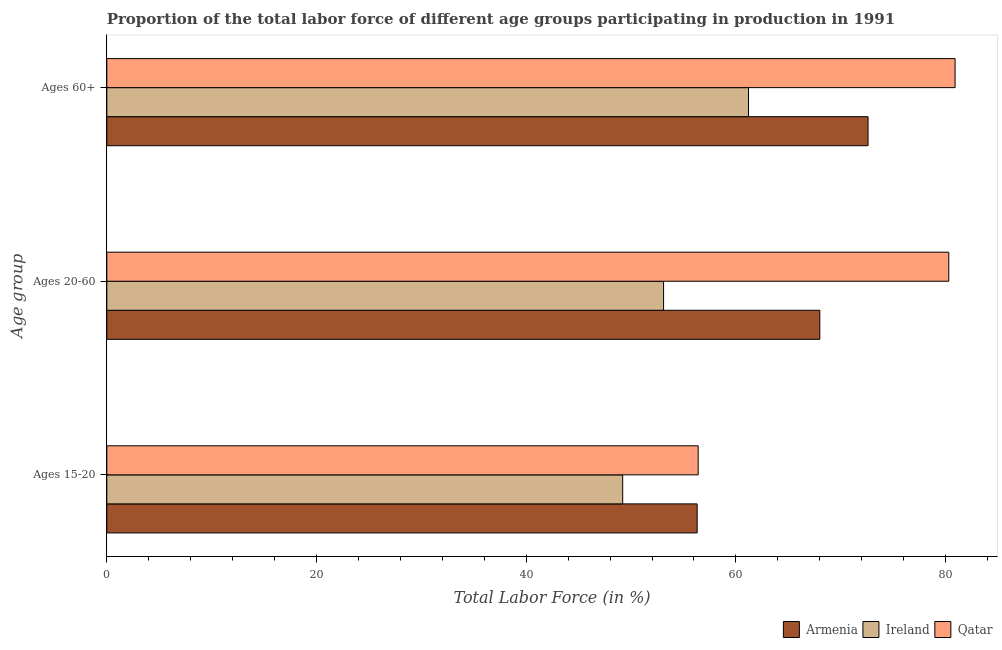How many different coloured bars are there?
Make the answer very short. 3. How many bars are there on the 1st tick from the top?
Offer a very short reply. 3. What is the label of the 1st group of bars from the top?
Offer a terse response. Ages 60+. What is the percentage of labor force within the age group 15-20 in Armenia?
Offer a terse response. 56.3. Across all countries, what is the maximum percentage of labor force within the age group 15-20?
Offer a terse response. 56.4. Across all countries, what is the minimum percentage of labor force within the age group 15-20?
Your answer should be compact. 49.2. In which country was the percentage of labor force within the age group 20-60 maximum?
Keep it short and to the point. Qatar. In which country was the percentage of labor force within the age group 15-20 minimum?
Your answer should be very brief. Ireland. What is the total percentage of labor force within the age group 20-60 in the graph?
Offer a terse response. 201.4. What is the difference between the percentage of labor force above age 60 in Qatar and that in Ireland?
Provide a short and direct response. 19.7. What is the difference between the percentage of labor force above age 60 in Armenia and the percentage of labor force within the age group 20-60 in Ireland?
Your answer should be compact. 19.5. What is the average percentage of labor force above age 60 per country?
Offer a terse response. 71.57. What is the difference between the percentage of labor force within the age group 20-60 and percentage of labor force within the age group 15-20 in Armenia?
Your response must be concise. 11.7. In how many countries, is the percentage of labor force within the age group 15-20 greater than 32 %?
Make the answer very short. 3. What is the ratio of the percentage of labor force within the age group 20-60 in Armenia to that in Qatar?
Give a very brief answer. 0.85. Is the percentage of labor force within the age group 15-20 in Ireland less than that in Armenia?
Give a very brief answer. Yes. Is the difference between the percentage of labor force within the age group 20-60 in Qatar and Ireland greater than the difference between the percentage of labor force within the age group 15-20 in Qatar and Ireland?
Ensure brevity in your answer.  Yes. What is the difference between the highest and the second highest percentage of labor force within the age group 15-20?
Offer a terse response. 0.1. What is the difference between the highest and the lowest percentage of labor force within the age group 15-20?
Ensure brevity in your answer.  7.2. In how many countries, is the percentage of labor force within the age group 15-20 greater than the average percentage of labor force within the age group 15-20 taken over all countries?
Your answer should be very brief. 2. What does the 2nd bar from the top in Ages 20-60 represents?
Ensure brevity in your answer.  Ireland. What does the 1st bar from the bottom in Ages 60+ represents?
Offer a very short reply. Armenia. Is it the case that in every country, the sum of the percentage of labor force within the age group 15-20 and percentage of labor force within the age group 20-60 is greater than the percentage of labor force above age 60?
Provide a short and direct response. Yes. What is the difference between two consecutive major ticks on the X-axis?
Offer a terse response. 20. Where does the legend appear in the graph?
Your answer should be very brief. Bottom right. How are the legend labels stacked?
Give a very brief answer. Horizontal. What is the title of the graph?
Ensure brevity in your answer.  Proportion of the total labor force of different age groups participating in production in 1991. Does "Bolivia" appear as one of the legend labels in the graph?
Your response must be concise. No. What is the label or title of the Y-axis?
Provide a succinct answer. Age group. What is the Total Labor Force (in %) of Armenia in Ages 15-20?
Make the answer very short. 56.3. What is the Total Labor Force (in %) of Ireland in Ages 15-20?
Ensure brevity in your answer.  49.2. What is the Total Labor Force (in %) of Qatar in Ages 15-20?
Make the answer very short. 56.4. What is the Total Labor Force (in %) of Ireland in Ages 20-60?
Make the answer very short. 53.1. What is the Total Labor Force (in %) of Qatar in Ages 20-60?
Provide a succinct answer. 80.3. What is the Total Labor Force (in %) of Armenia in Ages 60+?
Your answer should be compact. 72.6. What is the Total Labor Force (in %) in Ireland in Ages 60+?
Provide a short and direct response. 61.2. What is the Total Labor Force (in %) of Qatar in Ages 60+?
Offer a terse response. 80.9. Across all Age group, what is the maximum Total Labor Force (in %) in Armenia?
Give a very brief answer. 72.6. Across all Age group, what is the maximum Total Labor Force (in %) of Ireland?
Ensure brevity in your answer.  61.2. Across all Age group, what is the maximum Total Labor Force (in %) of Qatar?
Offer a terse response. 80.9. Across all Age group, what is the minimum Total Labor Force (in %) in Armenia?
Your answer should be very brief. 56.3. Across all Age group, what is the minimum Total Labor Force (in %) of Ireland?
Offer a terse response. 49.2. Across all Age group, what is the minimum Total Labor Force (in %) in Qatar?
Your answer should be compact. 56.4. What is the total Total Labor Force (in %) of Armenia in the graph?
Make the answer very short. 196.9. What is the total Total Labor Force (in %) of Ireland in the graph?
Offer a very short reply. 163.5. What is the total Total Labor Force (in %) of Qatar in the graph?
Your answer should be very brief. 217.6. What is the difference between the Total Labor Force (in %) in Armenia in Ages 15-20 and that in Ages 20-60?
Give a very brief answer. -11.7. What is the difference between the Total Labor Force (in %) in Qatar in Ages 15-20 and that in Ages 20-60?
Provide a short and direct response. -23.9. What is the difference between the Total Labor Force (in %) in Armenia in Ages 15-20 and that in Ages 60+?
Keep it short and to the point. -16.3. What is the difference between the Total Labor Force (in %) of Ireland in Ages 15-20 and that in Ages 60+?
Your response must be concise. -12. What is the difference between the Total Labor Force (in %) in Qatar in Ages 15-20 and that in Ages 60+?
Your answer should be very brief. -24.5. What is the difference between the Total Labor Force (in %) in Armenia in Ages 20-60 and that in Ages 60+?
Your answer should be compact. -4.6. What is the difference between the Total Labor Force (in %) in Qatar in Ages 20-60 and that in Ages 60+?
Your answer should be compact. -0.6. What is the difference between the Total Labor Force (in %) in Armenia in Ages 15-20 and the Total Labor Force (in %) in Qatar in Ages 20-60?
Offer a terse response. -24. What is the difference between the Total Labor Force (in %) in Ireland in Ages 15-20 and the Total Labor Force (in %) in Qatar in Ages 20-60?
Provide a succinct answer. -31.1. What is the difference between the Total Labor Force (in %) in Armenia in Ages 15-20 and the Total Labor Force (in %) in Qatar in Ages 60+?
Keep it short and to the point. -24.6. What is the difference between the Total Labor Force (in %) of Ireland in Ages 15-20 and the Total Labor Force (in %) of Qatar in Ages 60+?
Offer a terse response. -31.7. What is the difference between the Total Labor Force (in %) of Armenia in Ages 20-60 and the Total Labor Force (in %) of Ireland in Ages 60+?
Offer a very short reply. 6.8. What is the difference between the Total Labor Force (in %) in Armenia in Ages 20-60 and the Total Labor Force (in %) in Qatar in Ages 60+?
Ensure brevity in your answer.  -12.9. What is the difference between the Total Labor Force (in %) in Ireland in Ages 20-60 and the Total Labor Force (in %) in Qatar in Ages 60+?
Your response must be concise. -27.8. What is the average Total Labor Force (in %) in Armenia per Age group?
Offer a very short reply. 65.63. What is the average Total Labor Force (in %) in Ireland per Age group?
Your answer should be very brief. 54.5. What is the average Total Labor Force (in %) in Qatar per Age group?
Your answer should be compact. 72.53. What is the difference between the Total Labor Force (in %) in Armenia and Total Labor Force (in %) in Ireland in Ages 15-20?
Give a very brief answer. 7.1. What is the difference between the Total Labor Force (in %) of Ireland and Total Labor Force (in %) of Qatar in Ages 15-20?
Make the answer very short. -7.2. What is the difference between the Total Labor Force (in %) of Armenia and Total Labor Force (in %) of Ireland in Ages 20-60?
Give a very brief answer. 14.9. What is the difference between the Total Labor Force (in %) in Armenia and Total Labor Force (in %) in Qatar in Ages 20-60?
Provide a short and direct response. -12.3. What is the difference between the Total Labor Force (in %) of Ireland and Total Labor Force (in %) of Qatar in Ages 20-60?
Make the answer very short. -27.2. What is the difference between the Total Labor Force (in %) of Ireland and Total Labor Force (in %) of Qatar in Ages 60+?
Ensure brevity in your answer.  -19.7. What is the ratio of the Total Labor Force (in %) of Armenia in Ages 15-20 to that in Ages 20-60?
Provide a succinct answer. 0.83. What is the ratio of the Total Labor Force (in %) of Ireland in Ages 15-20 to that in Ages 20-60?
Provide a short and direct response. 0.93. What is the ratio of the Total Labor Force (in %) in Qatar in Ages 15-20 to that in Ages 20-60?
Provide a succinct answer. 0.7. What is the ratio of the Total Labor Force (in %) of Armenia in Ages 15-20 to that in Ages 60+?
Ensure brevity in your answer.  0.78. What is the ratio of the Total Labor Force (in %) of Ireland in Ages 15-20 to that in Ages 60+?
Provide a succinct answer. 0.8. What is the ratio of the Total Labor Force (in %) in Qatar in Ages 15-20 to that in Ages 60+?
Make the answer very short. 0.7. What is the ratio of the Total Labor Force (in %) in Armenia in Ages 20-60 to that in Ages 60+?
Your answer should be compact. 0.94. What is the ratio of the Total Labor Force (in %) in Ireland in Ages 20-60 to that in Ages 60+?
Make the answer very short. 0.87. What is the ratio of the Total Labor Force (in %) in Qatar in Ages 20-60 to that in Ages 60+?
Keep it short and to the point. 0.99. What is the difference between the highest and the second highest Total Labor Force (in %) in Armenia?
Keep it short and to the point. 4.6. 